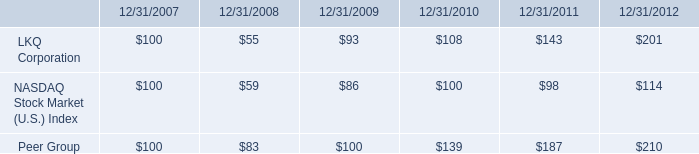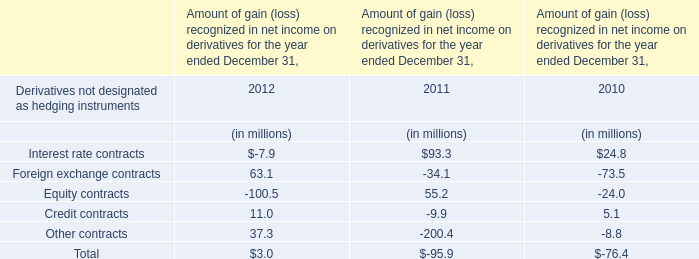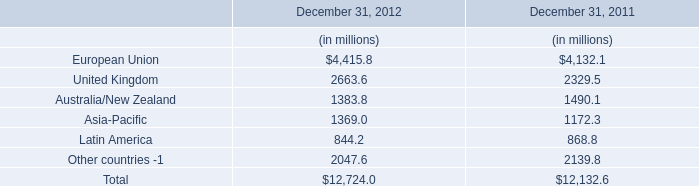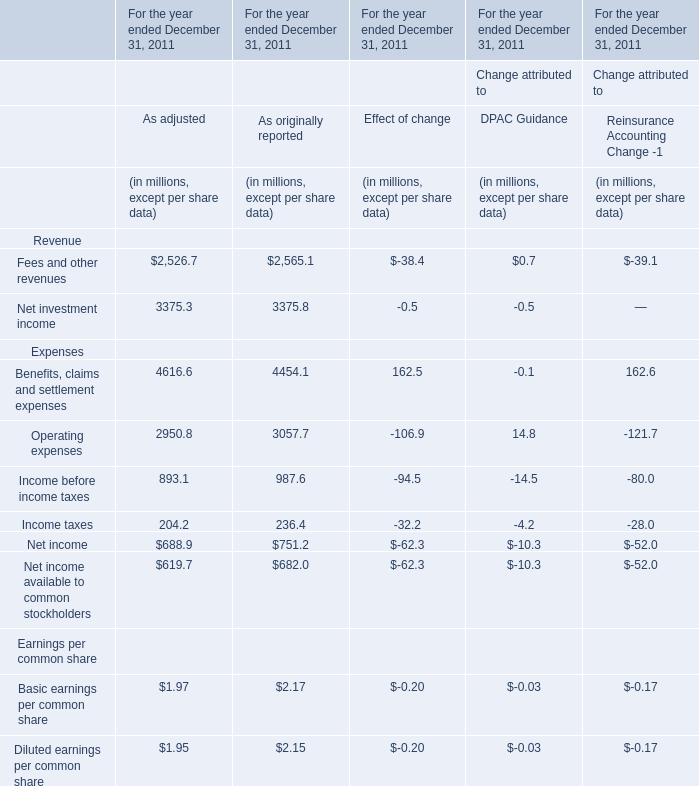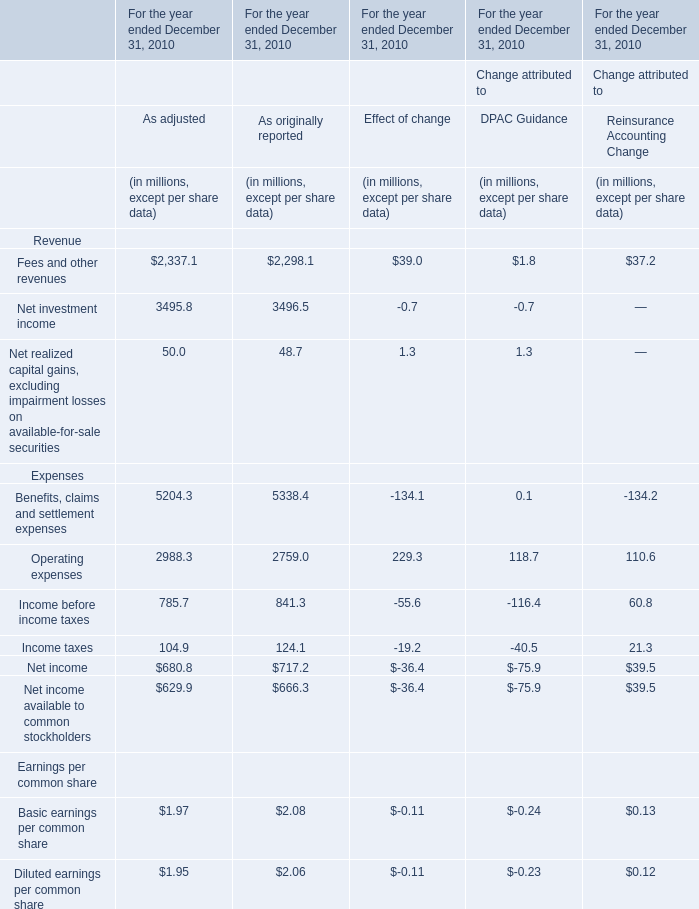What was the sum of Reinsurance Accounting Change without those Reinsurance Accounting Change greater than 20, in 2010? (in million) 
Computations: ((-134.2 + 0.13) + 0.12)
Answer: -133.95. 